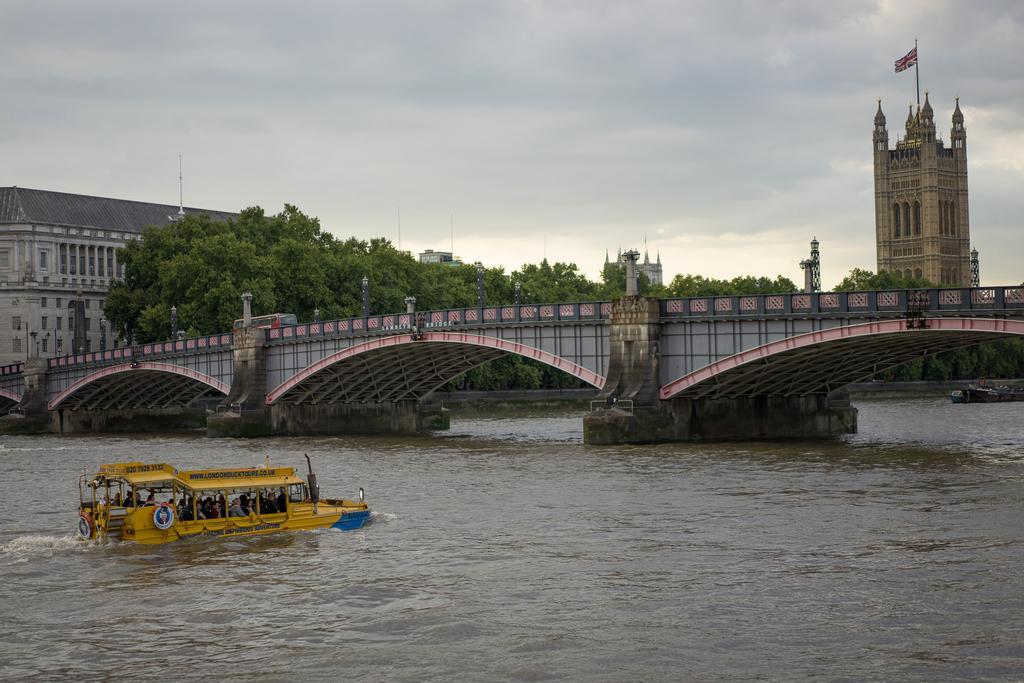Please provide a concise description of this image. In the image we can see there is a boat in the water and there are people in the boat. There is a bridge and there are many trees, and buildings. This is a flag and a cloudy sky. 